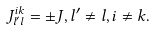Convert formula to latex. <formula><loc_0><loc_0><loc_500><loc_500>J ^ { i k } _ { l ^ { \prime } l } = \pm J , l ^ { \prime } \neq l , i \neq k .</formula> 